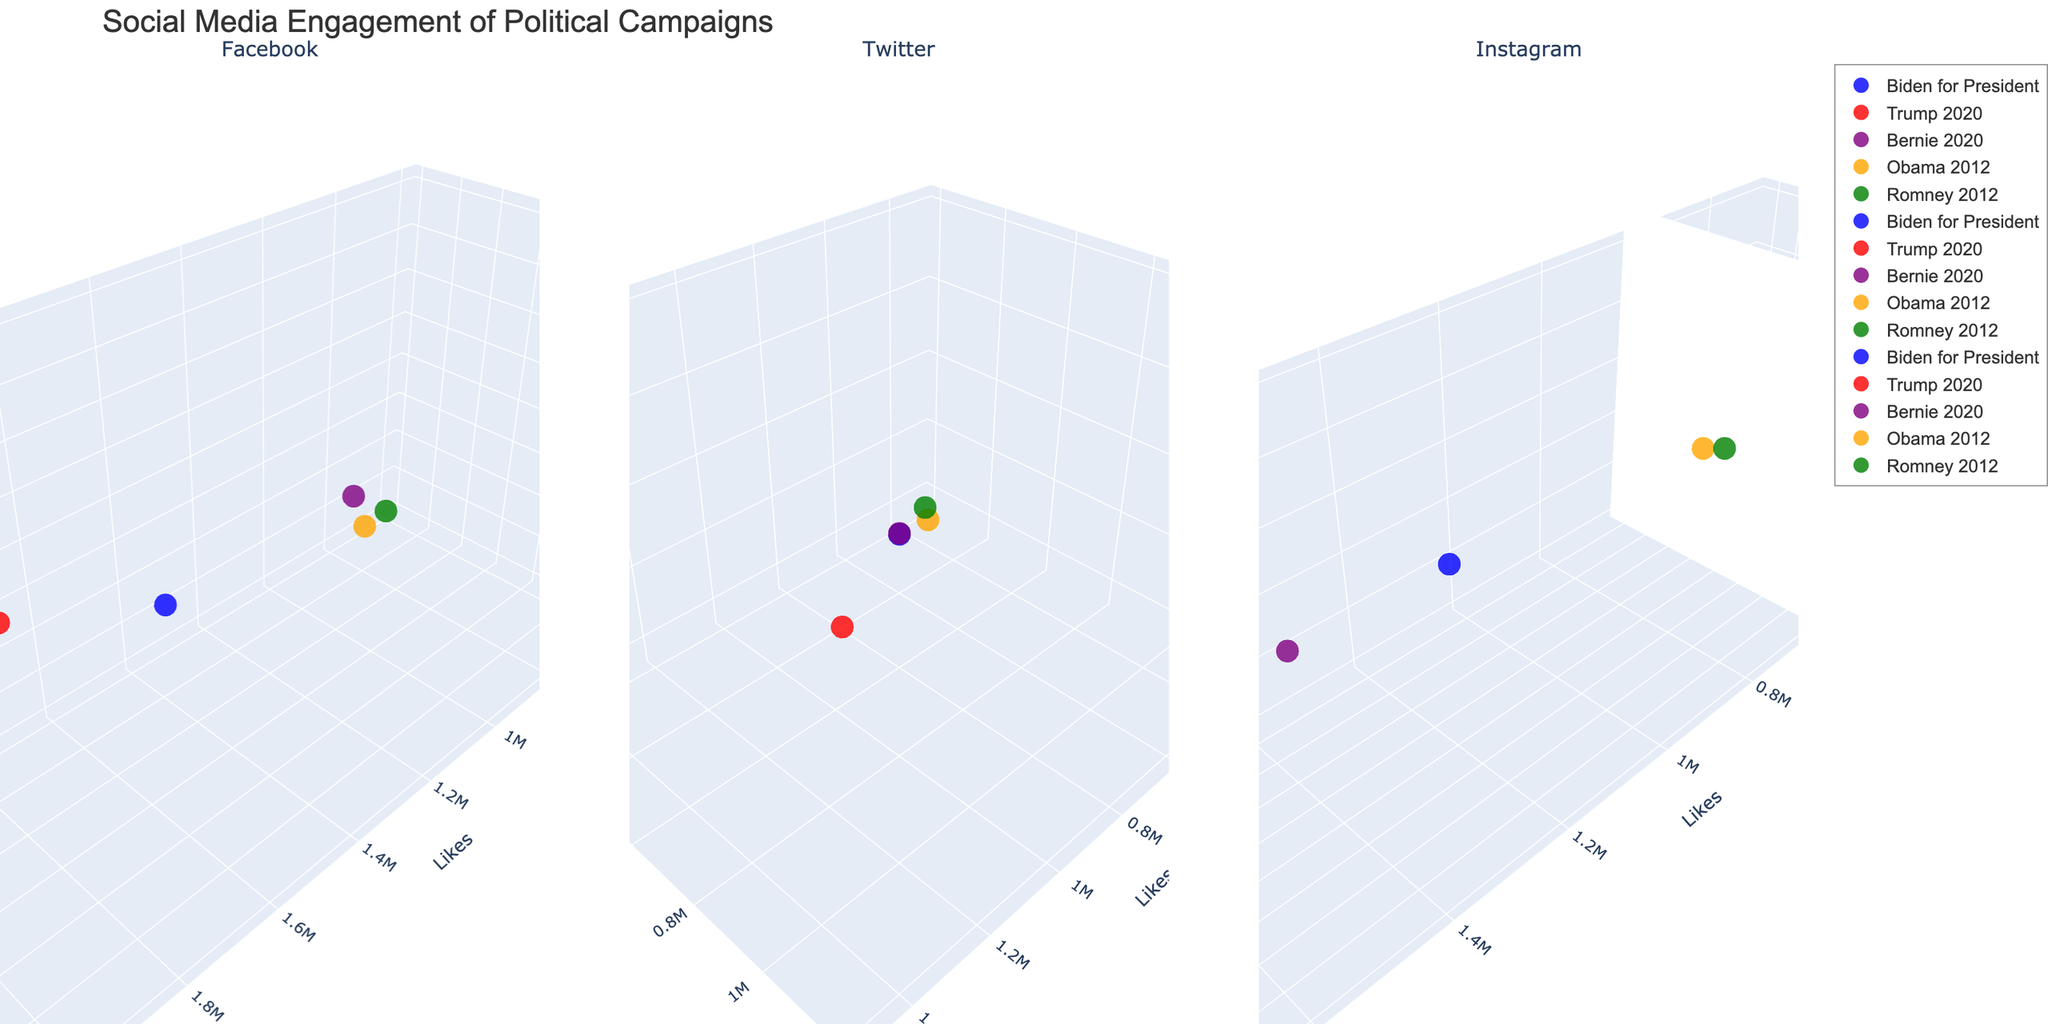Which campaign had more likes on Facebook in 2020, Biden for President or Trump 2020? Refer to the 3D subplot for Facebook in the figure, look for the highest 'Likes' value for each campaign in 2020. Trump 2020 had 2,000,000 likes, whereas Biden for President had 1,500,000.
Answer: Trump 2020 How do the shares of Bernie's 2020 campaign on Twitter compare to Obama's 2012 campaign on the same platform? Refer to the 3D subplot for Twitter in the figure and compare the 'Shares' values for Bernie's 2020 campaign (800,000) with Obama's 2012 campaign (400,000).
Answer: Bernie's campaign has twice as many shares Which platform did Romney's 2012 campaign receive the fewest likes on? Refer to the figure and check the 'Likes' values for Romney's 2012 campaign across Facebook, Twitter, and Instagram. The values are 600,000 (Facebook), 300,000 (Twitter), and 300,000 (Instagram). The lowest value is on Twitter and Instagram.
Answer: Twitter and Instagram What is the total number of comments across all platforms for Trump 2020? Add the 'Comments' values for Trump 2020 from Facebook, Twitter, and Instagram: 1,200,000 (Facebook) + 1,000,000 (Twitter) + 600,000 (Instagram) = 2,800,000 comments.
Answer: 2,800,000 Between Biden for President and Bernie 2020, which campaign had higher social media engagement on Instagram in terms of shares? Refer to the 3D subplot for Instagram in the figure and compare the 'Shares' values, which are 300,000 for Biden and 400,000 for Bernie.
Answer: Bernie 2020 Which campaign had fewer likes on Facebook in 2012, Obama 2012 or Romney 2012? Refer to the 3D subplot for Facebook and compare the 'Likes' values. Obama 2012 had 800,000 likes and Romney 2012 had 600,000 likes.
Answer: Romney 2012 Who had more shares on Twitter in 2020, Biden for President or Trump 2020? Refer to the 3D subplot for Twitter, where Biden's campaign has 700,000 shares and Trump's campaign has 1,200,000 shares.
Answer: Trump 2020 Which candidate's campaign data point appears closest to the origin in the Facebook subplot? The campaign closest to the origin (0,0,0) on Facebook will have the lowest 'Likes,' 'Shares,' and 'Comments.' Romney 2012's point with 600,000 likes, 200,000 shares, and 400,000 comments appears closest to the origin compared to other campaigns on Facebook.
Answer: Romney 2012 